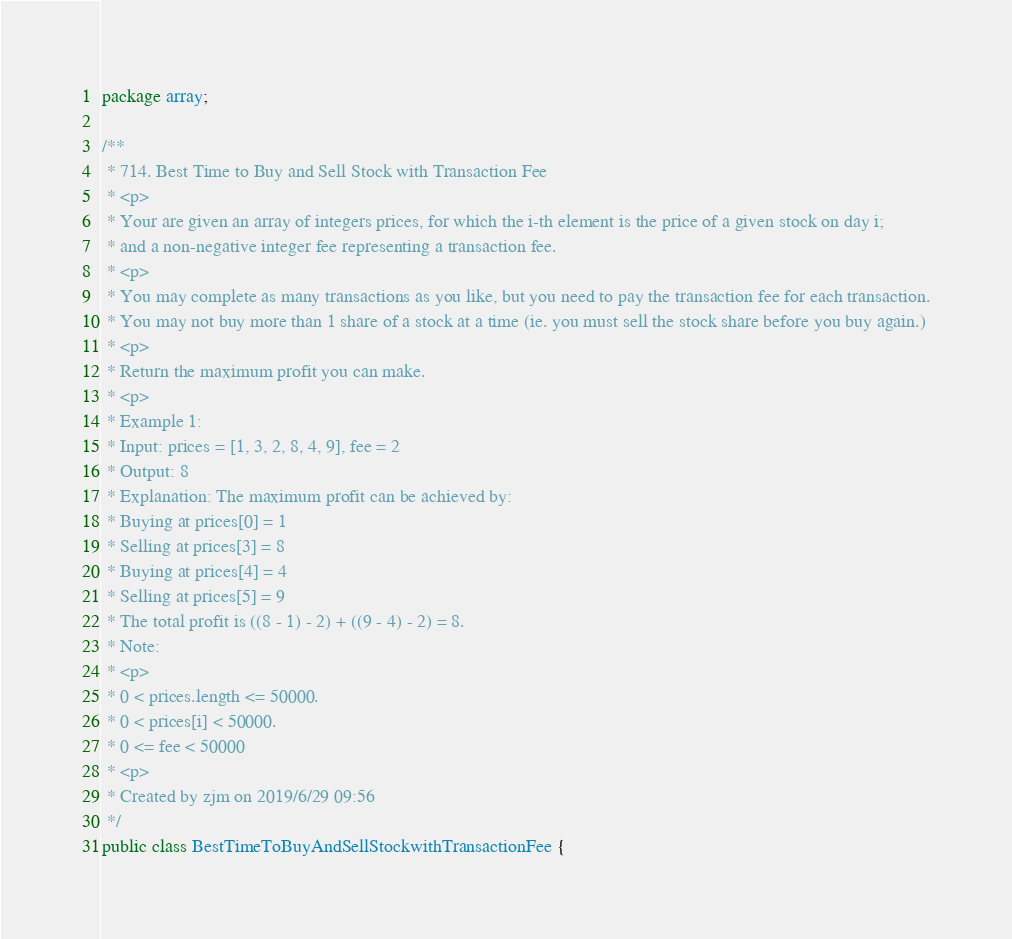<code> <loc_0><loc_0><loc_500><loc_500><_Java_>package array;

/**
 * 714. Best Time to Buy and Sell Stock with Transaction Fee
 * <p>
 * Your are given an array of integers prices, for which the i-th element is the price of a given stock on day i;
 * and a non-negative integer fee representing a transaction fee.
 * <p>
 * You may complete as many transactions as you like, but you need to pay the transaction fee for each transaction.
 * You may not buy more than 1 share of a stock at a time (ie. you must sell the stock share before you buy again.)
 * <p>
 * Return the maximum profit you can make.
 * <p>
 * Example 1:
 * Input: prices = [1, 3, 2, 8, 4, 9], fee = 2
 * Output: 8
 * Explanation: The maximum profit can be achieved by:
 * Buying at prices[0] = 1
 * Selling at prices[3] = 8
 * Buying at prices[4] = 4
 * Selling at prices[5] = 9
 * The total profit is ((8 - 1) - 2) + ((9 - 4) - 2) = 8.
 * Note:
 * <p>
 * 0 < prices.length <= 50000.
 * 0 < prices[i] < 50000.
 * 0 <= fee < 50000
 * <p>
 * Created by zjm on 2019/6/29 09:56
 */
public class BestTimeToBuyAndSellStockwithTransactionFee {
</code> 